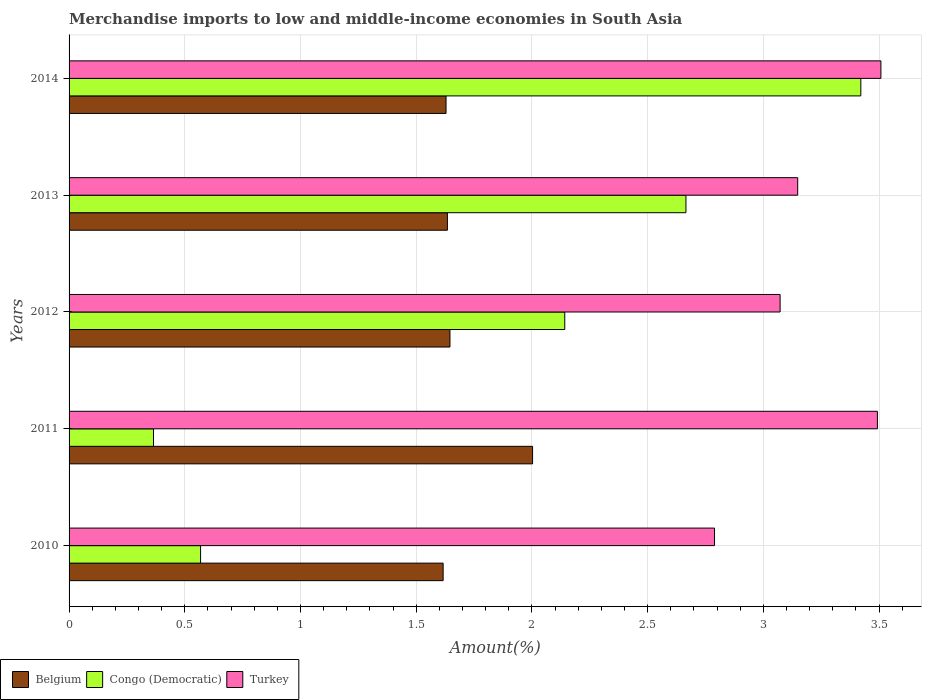How many different coloured bars are there?
Your answer should be very brief. 3. How many groups of bars are there?
Your answer should be very brief. 5. Are the number of bars per tick equal to the number of legend labels?
Your answer should be very brief. Yes. Are the number of bars on each tick of the Y-axis equal?
Offer a very short reply. Yes. In how many cases, is the number of bars for a given year not equal to the number of legend labels?
Your response must be concise. 0. What is the percentage of amount earned from merchandise imports in Belgium in 2014?
Provide a short and direct response. 1.63. Across all years, what is the maximum percentage of amount earned from merchandise imports in Turkey?
Provide a short and direct response. 3.51. Across all years, what is the minimum percentage of amount earned from merchandise imports in Belgium?
Offer a terse response. 1.62. In which year was the percentage of amount earned from merchandise imports in Turkey minimum?
Provide a short and direct response. 2010. What is the total percentage of amount earned from merchandise imports in Turkey in the graph?
Provide a succinct answer. 16.01. What is the difference between the percentage of amount earned from merchandise imports in Congo (Democratic) in 2011 and that in 2012?
Give a very brief answer. -1.78. What is the difference between the percentage of amount earned from merchandise imports in Congo (Democratic) in 2010 and the percentage of amount earned from merchandise imports in Turkey in 2014?
Make the answer very short. -2.94. What is the average percentage of amount earned from merchandise imports in Congo (Democratic) per year?
Provide a short and direct response. 1.83. In the year 2012, what is the difference between the percentage of amount earned from merchandise imports in Turkey and percentage of amount earned from merchandise imports in Congo (Democratic)?
Your answer should be compact. 0.93. What is the ratio of the percentage of amount earned from merchandise imports in Congo (Democratic) in 2012 to that in 2014?
Offer a terse response. 0.63. Is the difference between the percentage of amount earned from merchandise imports in Turkey in 2011 and 2012 greater than the difference between the percentage of amount earned from merchandise imports in Congo (Democratic) in 2011 and 2012?
Give a very brief answer. Yes. What is the difference between the highest and the second highest percentage of amount earned from merchandise imports in Belgium?
Provide a short and direct response. 0.36. What is the difference between the highest and the lowest percentage of amount earned from merchandise imports in Congo (Democratic)?
Keep it short and to the point. 3.06. In how many years, is the percentage of amount earned from merchandise imports in Turkey greater than the average percentage of amount earned from merchandise imports in Turkey taken over all years?
Offer a very short reply. 2. Is the sum of the percentage of amount earned from merchandise imports in Congo (Democratic) in 2011 and 2014 greater than the maximum percentage of amount earned from merchandise imports in Belgium across all years?
Your answer should be compact. Yes. How many bars are there?
Provide a short and direct response. 15. Are all the bars in the graph horizontal?
Provide a short and direct response. Yes. How many years are there in the graph?
Your response must be concise. 5. What is the difference between two consecutive major ticks on the X-axis?
Make the answer very short. 0.5. Does the graph contain any zero values?
Keep it short and to the point. No. Does the graph contain grids?
Make the answer very short. Yes. Where does the legend appear in the graph?
Make the answer very short. Bottom left. How are the legend labels stacked?
Your answer should be compact. Horizontal. What is the title of the graph?
Keep it short and to the point. Merchandise imports to low and middle-income economies in South Asia. Does "Sao Tome and Principe" appear as one of the legend labels in the graph?
Give a very brief answer. No. What is the label or title of the X-axis?
Provide a short and direct response. Amount(%). What is the Amount(%) in Belgium in 2010?
Your answer should be very brief. 1.62. What is the Amount(%) of Congo (Democratic) in 2010?
Keep it short and to the point. 0.57. What is the Amount(%) in Turkey in 2010?
Your answer should be very brief. 2.79. What is the Amount(%) of Belgium in 2011?
Your response must be concise. 2. What is the Amount(%) in Congo (Democratic) in 2011?
Keep it short and to the point. 0.36. What is the Amount(%) of Turkey in 2011?
Ensure brevity in your answer.  3.49. What is the Amount(%) in Belgium in 2012?
Your response must be concise. 1.65. What is the Amount(%) of Congo (Democratic) in 2012?
Your answer should be very brief. 2.14. What is the Amount(%) in Turkey in 2012?
Your response must be concise. 3.07. What is the Amount(%) of Belgium in 2013?
Provide a short and direct response. 1.63. What is the Amount(%) in Congo (Democratic) in 2013?
Offer a very short reply. 2.67. What is the Amount(%) of Turkey in 2013?
Your answer should be very brief. 3.15. What is the Amount(%) of Belgium in 2014?
Make the answer very short. 1.63. What is the Amount(%) in Congo (Democratic) in 2014?
Your response must be concise. 3.42. What is the Amount(%) in Turkey in 2014?
Provide a succinct answer. 3.51. Across all years, what is the maximum Amount(%) in Belgium?
Give a very brief answer. 2. Across all years, what is the maximum Amount(%) in Congo (Democratic)?
Keep it short and to the point. 3.42. Across all years, what is the maximum Amount(%) in Turkey?
Make the answer very short. 3.51. Across all years, what is the minimum Amount(%) in Belgium?
Your answer should be compact. 1.62. Across all years, what is the minimum Amount(%) of Congo (Democratic)?
Provide a succinct answer. 0.36. Across all years, what is the minimum Amount(%) of Turkey?
Provide a short and direct response. 2.79. What is the total Amount(%) of Belgium in the graph?
Offer a very short reply. 8.53. What is the total Amount(%) of Congo (Democratic) in the graph?
Offer a terse response. 9.16. What is the total Amount(%) of Turkey in the graph?
Offer a very short reply. 16.01. What is the difference between the Amount(%) of Belgium in 2010 and that in 2011?
Your answer should be compact. -0.39. What is the difference between the Amount(%) in Congo (Democratic) in 2010 and that in 2011?
Your answer should be very brief. 0.2. What is the difference between the Amount(%) of Turkey in 2010 and that in 2011?
Ensure brevity in your answer.  -0.7. What is the difference between the Amount(%) in Belgium in 2010 and that in 2012?
Your response must be concise. -0.03. What is the difference between the Amount(%) of Congo (Democratic) in 2010 and that in 2012?
Ensure brevity in your answer.  -1.57. What is the difference between the Amount(%) in Turkey in 2010 and that in 2012?
Give a very brief answer. -0.28. What is the difference between the Amount(%) of Belgium in 2010 and that in 2013?
Your answer should be compact. -0.02. What is the difference between the Amount(%) of Congo (Democratic) in 2010 and that in 2013?
Provide a short and direct response. -2.1. What is the difference between the Amount(%) in Turkey in 2010 and that in 2013?
Ensure brevity in your answer.  -0.36. What is the difference between the Amount(%) of Belgium in 2010 and that in 2014?
Your answer should be very brief. -0.01. What is the difference between the Amount(%) in Congo (Democratic) in 2010 and that in 2014?
Give a very brief answer. -2.85. What is the difference between the Amount(%) in Turkey in 2010 and that in 2014?
Your answer should be very brief. -0.72. What is the difference between the Amount(%) in Belgium in 2011 and that in 2012?
Make the answer very short. 0.36. What is the difference between the Amount(%) of Congo (Democratic) in 2011 and that in 2012?
Your response must be concise. -1.78. What is the difference between the Amount(%) in Turkey in 2011 and that in 2012?
Your answer should be compact. 0.42. What is the difference between the Amount(%) in Belgium in 2011 and that in 2013?
Your answer should be very brief. 0.37. What is the difference between the Amount(%) of Congo (Democratic) in 2011 and that in 2013?
Your response must be concise. -2.3. What is the difference between the Amount(%) of Turkey in 2011 and that in 2013?
Offer a very short reply. 0.34. What is the difference between the Amount(%) of Belgium in 2011 and that in 2014?
Make the answer very short. 0.37. What is the difference between the Amount(%) in Congo (Democratic) in 2011 and that in 2014?
Provide a short and direct response. -3.06. What is the difference between the Amount(%) in Turkey in 2011 and that in 2014?
Give a very brief answer. -0.02. What is the difference between the Amount(%) in Belgium in 2012 and that in 2013?
Make the answer very short. 0.01. What is the difference between the Amount(%) of Congo (Democratic) in 2012 and that in 2013?
Offer a terse response. -0.52. What is the difference between the Amount(%) in Turkey in 2012 and that in 2013?
Make the answer very short. -0.08. What is the difference between the Amount(%) of Belgium in 2012 and that in 2014?
Ensure brevity in your answer.  0.02. What is the difference between the Amount(%) of Congo (Democratic) in 2012 and that in 2014?
Offer a very short reply. -1.28. What is the difference between the Amount(%) of Turkey in 2012 and that in 2014?
Give a very brief answer. -0.44. What is the difference between the Amount(%) of Belgium in 2013 and that in 2014?
Provide a short and direct response. 0.01. What is the difference between the Amount(%) in Congo (Democratic) in 2013 and that in 2014?
Your answer should be compact. -0.76. What is the difference between the Amount(%) in Turkey in 2013 and that in 2014?
Provide a succinct answer. -0.36. What is the difference between the Amount(%) of Belgium in 2010 and the Amount(%) of Congo (Democratic) in 2011?
Provide a short and direct response. 1.25. What is the difference between the Amount(%) in Belgium in 2010 and the Amount(%) in Turkey in 2011?
Give a very brief answer. -1.88. What is the difference between the Amount(%) in Congo (Democratic) in 2010 and the Amount(%) in Turkey in 2011?
Your answer should be very brief. -2.92. What is the difference between the Amount(%) in Belgium in 2010 and the Amount(%) in Congo (Democratic) in 2012?
Your response must be concise. -0.53. What is the difference between the Amount(%) in Belgium in 2010 and the Amount(%) in Turkey in 2012?
Offer a very short reply. -1.46. What is the difference between the Amount(%) of Congo (Democratic) in 2010 and the Amount(%) of Turkey in 2012?
Your answer should be compact. -2.5. What is the difference between the Amount(%) of Belgium in 2010 and the Amount(%) of Congo (Democratic) in 2013?
Give a very brief answer. -1.05. What is the difference between the Amount(%) of Belgium in 2010 and the Amount(%) of Turkey in 2013?
Offer a very short reply. -1.53. What is the difference between the Amount(%) in Congo (Democratic) in 2010 and the Amount(%) in Turkey in 2013?
Offer a terse response. -2.58. What is the difference between the Amount(%) in Belgium in 2010 and the Amount(%) in Congo (Democratic) in 2014?
Your answer should be very brief. -1.8. What is the difference between the Amount(%) in Belgium in 2010 and the Amount(%) in Turkey in 2014?
Provide a short and direct response. -1.89. What is the difference between the Amount(%) in Congo (Democratic) in 2010 and the Amount(%) in Turkey in 2014?
Your answer should be very brief. -2.94. What is the difference between the Amount(%) of Belgium in 2011 and the Amount(%) of Congo (Democratic) in 2012?
Make the answer very short. -0.14. What is the difference between the Amount(%) in Belgium in 2011 and the Amount(%) in Turkey in 2012?
Ensure brevity in your answer.  -1.07. What is the difference between the Amount(%) in Congo (Democratic) in 2011 and the Amount(%) in Turkey in 2012?
Give a very brief answer. -2.71. What is the difference between the Amount(%) of Belgium in 2011 and the Amount(%) of Congo (Democratic) in 2013?
Your response must be concise. -0.66. What is the difference between the Amount(%) of Belgium in 2011 and the Amount(%) of Turkey in 2013?
Offer a terse response. -1.15. What is the difference between the Amount(%) of Congo (Democratic) in 2011 and the Amount(%) of Turkey in 2013?
Ensure brevity in your answer.  -2.78. What is the difference between the Amount(%) in Belgium in 2011 and the Amount(%) in Congo (Democratic) in 2014?
Give a very brief answer. -1.42. What is the difference between the Amount(%) in Belgium in 2011 and the Amount(%) in Turkey in 2014?
Your answer should be compact. -1.51. What is the difference between the Amount(%) of Congo (Democratic) in 2011 and the Amount(%) of Turkey in 2014?
Your answer should be very brief. -3.14. What is the difference between the Amount(%) in Belgium in 2012 and the Amount(%) in Congo (Democratic) in 2013?
Give a very brief answer. -1.02. What is the difference between the Amount(%) of Belgium in 2012 and the Amount(%) of Turkey in 2013?
Offer a terse response. -1.5. What is the difference between the Amount(%) of Congo (Democratic) in 2012 and the Amount(%) of Turkey in 2013?
Your answer should be very brief. -1.01. What is the difference between the Amount(%) of Belgium in 2012 and the Amount(%) of Congo (Democratic) in 2014?
Your response must be concise. -1.78. What is the difference between the Amount(%) in Belgium in 2012 and the Amount(%) in Turkey in 2014?
Offer a very short reply. -1.86. What is the difference between the Amount(%) in Congo (Democratic) in 2012 and the Amount(%) in Turkey in 2014?
Offer a very short reply. -1.37. What is the difference between the Amount(%) of Belgium in 2013 and the Amount(%) of Congo (Democratic) in 2014?
Your answer should be compact. -1.79. What is the difference between the Amount(%) in Belgium in 2013 and the Amount(%) in Turkey in 2014?
Provide a succinct answer. -1.87. What is the difference between the Amount(%) of Congo (Democratic) in 2013 and the Amount(%) of Turkey in 2014?
Provide a succinct answer. -0.84. What is the average Amount(%) of Belgium per year?
Provide a short and direct response. 1.71. What is the average Amount(%) in Congo (Democratic) per year?
Provide a succinct answer. 1.83. What is the average Amount(%) in Turkey per year?
Offer a very short reply. 3.2. In the year 2010, what is the difference between the Amount(%) of Belgium and Amount(%) of Congo (Democratic)?
Your response must be concise. 1.05. In the year 2010, what is the difference between the Amount(%) in Belgium and Amount(%) in Turkey?
Your answer should be very brief. -1.17. In the year 2010, what is the difference between the Amount(%) in Congo (Democratic) and Amount(%) in Turkey?
Ensure brevity in your answer.  -2.22. In the year 2011, what is the difference between the Amount(%) in Belgium and Amount(%) in Congo (Democratic)?
Offer a very short reply. 1.64. In the year 2011, what is the difference between the Amount(%) of Belgium and Amount(%) of Turkey?
Provide a short and direct response. -1.49. In the year 2011, what is the difference between the Amount(%) of Congo (Democratic) and Amount(%) of Turkey?
Provide a short and direct response. -3.13. In the year 2012, what is the difference between the Amount(%) in Belgium and Amount(%) in Congo (Democratic)?
Give a very brief answer. -0.5. In the year 2012, what is the difference between the Amount(%) of Belgium and Amount(%) of Turkey?
Ensure brevity in your answer.  -1.43. In the year 2012, what is the difference between the Amount(%) in Congo (Democratic) and Amount(%) in Turkey?
Make the answer very short. -0.93. In the year 2013, what is the difference between the Amount(%) in Belgium and Amount(%) in Congo (Democratic)?
Offer a very short reply. -1.03. In the year 2013, what is the difference between the Amount(%) of Belgium and Amount(%) of Turkey?
Provide a short and direct response. -1.51. In the year 2013, what is the difference between the Amount(%) of Congo (Democratic) and Amount(%) of Turkey?
Offer a terse response. -0.48. In the year 2014, what is the difference between the Amount(%) in Belgium and Amount(%) in Congo (Democratic)?
Ensure brevity in your answer.  -1.79. In the year 2014, what is the difference between the Amount(%) of Belgium and Amount(%) of Turkey?
Ensure brevity in your answer.  -1.88. In the year 2014, what is the difference between the Amount(%) in Congo (Democratic) and Amount(%) in Turkey?
Offer a terse response. -0.09. What is the ratio of the Amount(%) in Belgium in 2010 to that in 2011?
Give a very brief answer. 0.81. What is the ratio of the Amount(%) in Congo (Democratic) in 2010 to that in 2011?
Offer a very short reply. 1.56. What is the ratio of the Amount(%) of Turkey in 2010 to that in 2011?
Provide a short and direct response. 0.8. What is the ratio of the Amount(%) in Belgium in 2010 to that in 2012?
Make the answer very short. 0.98. What is the ratio of the Amount(%) of Congo (Democratic) in 2010 to that in 2012?
Give a very brief answer. 0.27. What is the ratio of the Amount(%) in Turkey in 2010 to that in 2012?
Ensure brevity in your answer.  0.91. What is the ratio of the Amount(%) of Congo (Democratic) in 2010 to that in 2013?
Provide a short and direct response. 0.21. What is the ratio of the Amount(%) of Turkey in 2010 to that in 2013?
Your response must be concise. 0.89. What is the ratio of the Amount(%) in Congo (Democratic) in 2010 to that in 2014?
Keep it short and to the point. 0.17. What is the ratio of the Amount(%) in Turkey in 2010 to that in 2014?
Make the answer very short. 0.8. What is the ratio of the Amount(%) in Belgium in 2011 to that in 2012?
Provide a succinct answer. 1.22. What is the ratio of the Amount(%) in Congo (Democratic) in 2011 to that in 2012?
Your answer should be very brief. 0.17. What is the ratio of the Amount(%) of Turkey in 2011 to that in 2012?
Make the answer very short. 1.14. What is the ratio of the Amount(%) of Belgium in 2011 to that in 2013?
Your answer should be compact. 1.23. What is the ratio of the Amount(%) in Congo (Democratic) in 2011 to that in 2013?
Your response must be concise. 0.14. What is the ratio of the Amount(%) in Turkey in 2011 to that in 2013?
Keep it short and to the point. 1.11. What is the ratio of the Amount(%) in Belgium in 2011 to that in 2014?
Your answer should be compact. 1.23. What is the ratio of the Amount(%) in Congo (Democratic) in 2011 to that in 2014?
Provide a short and direct response. 0.11. What is the ratio of the Amount(%) of Belgium in 2012 to that in 2013?
Keep it short and to the point. 1.01. What is the ratio of the Amount(%) of Congo (Democratic) in 2012 to that in 2013?
Your answer should be compact. 0.8. What is the ratio of the Amount(%) in Turkey in 2012 to that in 2013?
Make the answer very short. 0.98. What is the ratio of the Amount(%) of Belgium in 2012 to that in 2014?
Offer a terse response. 1.01. What is the ratio of the Amount(%) of Congo (Democratic) in 2012 to that in 2014?
Offer a very short reply. 0.63. What is the ratio of the Amount(%) of Turkey in 2012 to that in 2014?
Provide a short and direct response. 0.88. What is the ratio of the Amount(%) in Congo (Democratic) in 2013 to that in 2014?
Offer a very short reply. 0.78. What is the ratio of the Amount(%) in Turkey in 2013 to that in 2014?
Provide a succinct answer. 0.9. What is the difference between the highest and the second highest Amount(%) of Belgium?
Offer a very short reply. 0.36. What is the difference between the highest and the second highest Amount(%) in Congo (Democratic)?
Your answer should be very brief. 0.76. What is the difference between the highest and the second highest Amount(%) of Turkey?
Ensure brevity in your answer.  0.02. What is the difference between the highest and the lowest Amount(%) in Belgium?
Ensure brevity in your answer.  0.39. What is the difference between the highest and the lowest Amount(%) in Congo (Democratic)?
Provide a short and direct response. 3.06. What is the difference between the highest and the lowest Amount(%) of Turkey?
Your answer should be very brief. 0.72. 